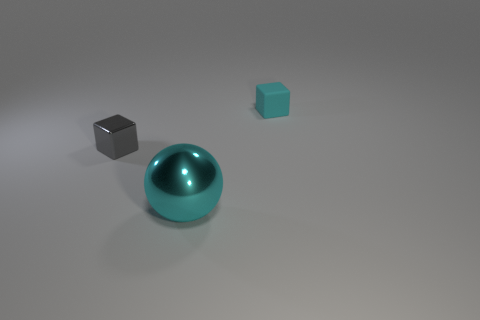What number of cubes are shiny objects or big gray objects?
Your answer should be compact. 1. There is a tiny object that is in front of the cube that is on the right side of the small gray shiny block; are there any large cyan metallic objects behind it?
Offer a very short reply. No. There is a matte object that is the same shape as the small gray metallic thing; what color is it?
Your response must be concise. Cyan. How many purple things are either large metal objects or blocks?
Make the answer very short. 0. What is the material of the cube right of the small cube that is left of the small matte thing?
Make the answer very short. Rubber. Do the tiny cyan thing and the big thing have the same shape?
Offer a terse response. No. What is the color of the thing that is the same size as the gray cube?
Make the answer very short. Cyan. Is there a small rubber cube that has the same color as the tiny shiny object?
Keep it short and to the point. No. Is there a purple rubber cube?
Offer a very short reply. No. Does the cyan thing on the left side of the matte block have the same material as the gray thing?
Your answer should be compact. Yes. 